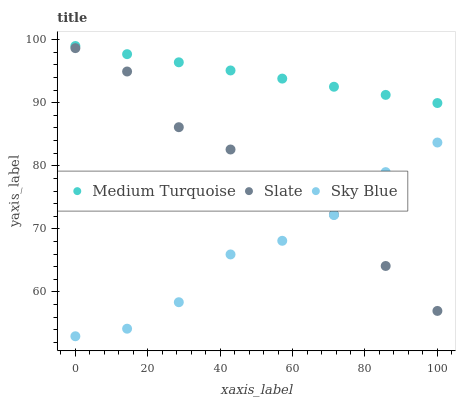Does Sky Blue have the minimum area under the curve?
Answer yes or no. Yes. Does Medium Turquoise have the maximum area under the curve?
Answer yes or no. Yes. Does Slate have the minimum area under the curve?
Answer yes or no. No. Does Slate have the maximum area under the curve?
Answer yes or no. No. Is Medium Turquoise the smoothest?
Answer yes or no. Yes. Is Sky Blue the roughest?
Answer yes or no. Yes. Is Slate the smoothest?
Answer yes or no. No. Is Slate the roughest?
Answer yes or no. No. Does Sky Blue have the lowest value?
Answer yes or no. Yes. Does Slate have the lowest value?
Answer yes or no. No. Does Medium Turquoise have the highest value?
Answer yes or no. Yes. Does Slate have the highest value?
Answer yes or no. No. Is Slate less than Medium Turquoise?
Answer yes or no. Yes. Is Medium Turquoise greater than Slate?
Answer yes or no. Yes. Does Sky Blue intersect Slate?
Answer yes or no. Yes. Is Sky Blue less than Slate?
Answer yes or no. No. Is Sky Blue greater than Slate?
Answer yes or no. No. Does Slate intersect Medium Turquoise?
Answer yes or no. No. 